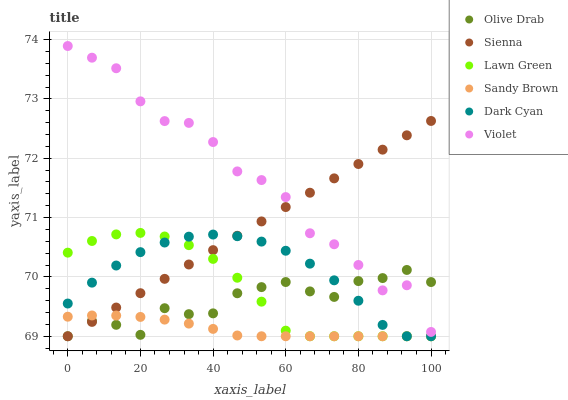Does Sandy Brown have the minimum area under the curve?
Answer yes or no. Yes. Does Violet have the maximum area under the curve?
Answer yes or no. Yes. Does Sienna have the minimum area under the curve?
Answer yes or no. No. Does Sienna have the maximum area under the curve?
Answer yes or no. No. Is Sienna the smoothest?
Answer yes or no. Yes. Is Violet the roughest?
Answer yes or no. Yes. Is Violet the smoothest?
Answer yes or no. No. Is Sienna the roughest?
Answer yes or no. No. Does Lawn Green have the lowest value?
Answer yes or no. Yes. Does Violet have the lowest value?
Answer yes or no. No. Does Violet have the highest value?
Answer yes or no. Yes. Does Sienna have the highest value?
Answer yes or no. No. Is Sandy Brown less than Violet?
Answer yes or no. Yes. Is Violet greater than Sandy Brown?
Answer yes or no. Yes. Does Dark Cyan intersect Lawn Green?
Answer yes or no. Yes. Is Dark Cyan less than Lawn Green?
Answer yes or no. No. Is Dark Cyan greater than Lawn Green?
Answer yes or no. No. Does Sandy Brown intersect Violet?
Answer yes or no. No. 